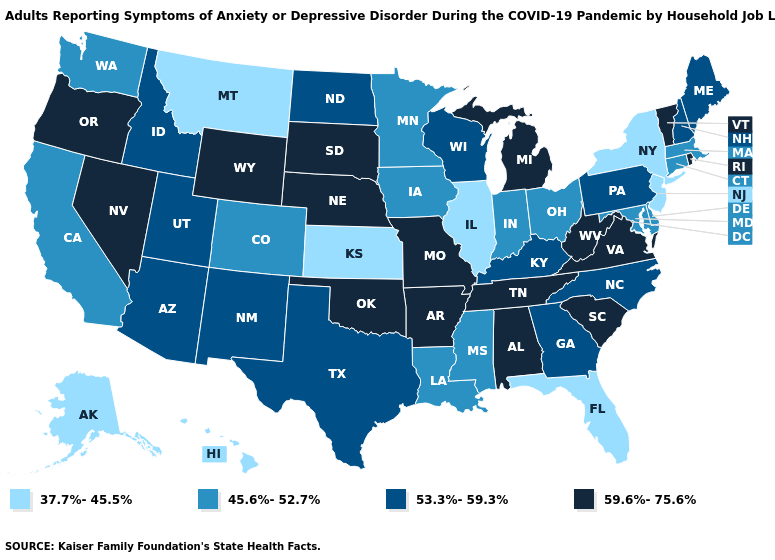Name the states that have a value in the range 59.6%-75.6%?
Give a very brief answer. Alabama, Arkansas, Michigan, Missouri, Nebraska, Nevada, Oklahoma, Oregon, Rhode Island, South Carolina, South Dakota, Tennessee, Vermont, Virginia, West Virginia, Wyoming. Name the states that have a value in the range 45.6%-52.7%?
Short answer required. California, Colorado, Connecticut, Delaware, Indiana, Iowa, Louisiana, Maryland, Massachusetts, Minnesota, Mississippi, Ohio, Washington. Name the states that have a value in the range 59.6%-75.6%?
Give a very brief answer. Alabama, Arkansas, Michigan, Missouri, Nebraska, Nevada, Oklahoma, Oregon, Rhode Island, South Carolina, South Dakota, Tennessee, Vermont, Virginia, West Virginia, Wyoming. What is the value of Arizona?
Short answer required. 53.3%-59.3%. Name the states that have a value in the range 45.6%-52.7%?
Be succinct. California, Colorado, Connecticut, Delaware, Indiana, Iowa, Louisiana, Maryland, Massachusetts, Minnesota, Mississippi, Ohio, Washington. What is the value of Illinois?
Give a very brief answer. 37.7%-45.5%. Name the states that have a value in the range 45.6%-52.7%?
Give a very brief answer. California, Colorado, Connecticut, Delaware, Indiana, Iowa, Louisiana, Maryland, Massachusetts, Minnesota, Mississippi, Ohio, Washington. Does Nevada have the highest value in the West?
Concise answer only. Yes. Among the states that border Washington , which have the highest value?
Concise answer only. Oregon. What is the value of Georgia?
Short answer required. 53.3%-59.3%. Which states have the lowest value in the USA?
Give a very brief answer. Alaska, Florida, Hawaii, Illinois, Kansas, Montana, New Jersey, New York. What is the value of Ohio?
Quick response, please. 45.6%-52.7%. Name the states that have a value in the range 37.7%-45.5%?
Answer briefly. Alaska, Florida, Hawaii, Illinois, Kansas, Montana, New Jersey, New York. Name the states that have a value in the range 59.6%-75.6%?
Give a very brief answer. Alabama, Arkansas, Michigan, Missouri, Nebraska, Nevada, Oklahoma, Oregon, Rhode Island, South Carolina, South Dakota, Tennessee, Vermont, Virginia, West Virginia, Wyoming. What is the value of Colorado?
Quick response, please. 45.6%-52.7%. 